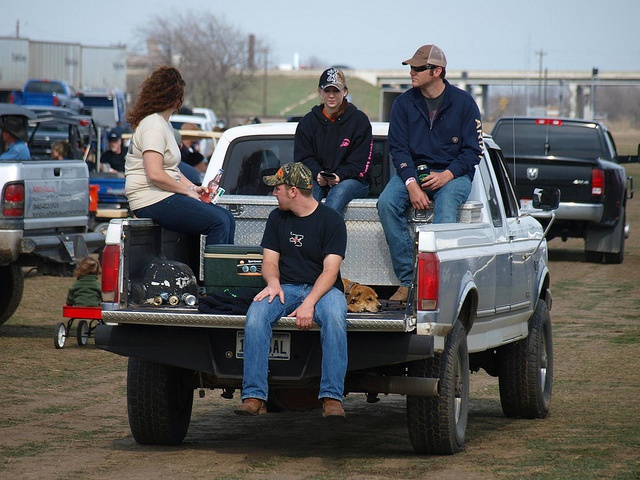Describe the objects in this image and their specific colors. I can see truck in lightblue, black, gray, darkgray, and blue tones, people in lightblue, black, blue, and salmon tones, people in lightblue, black, navy, blue, and gray tones, truck in lightblue, black, gray, blue, and darkblue tones, and people in lightblue, black, lightgray, darkgray, and tan tones in this image. 